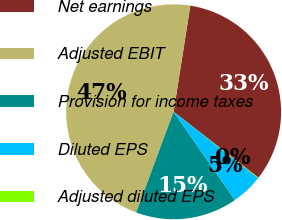<chart> <loc_0><loc_0><loc_500><loc_500><pie_chart><fcel>Net earnings<fcel>Adjusted EBIT<fcel>Provision for income taxes<fcel>Diluted EPS<fcel>Adjusted diluted EPS<nl><fcel>33.04%<fcel>46.82%<fcel>15.32%<fcel>4.75%<fcel>0.07%<nl></chart> 